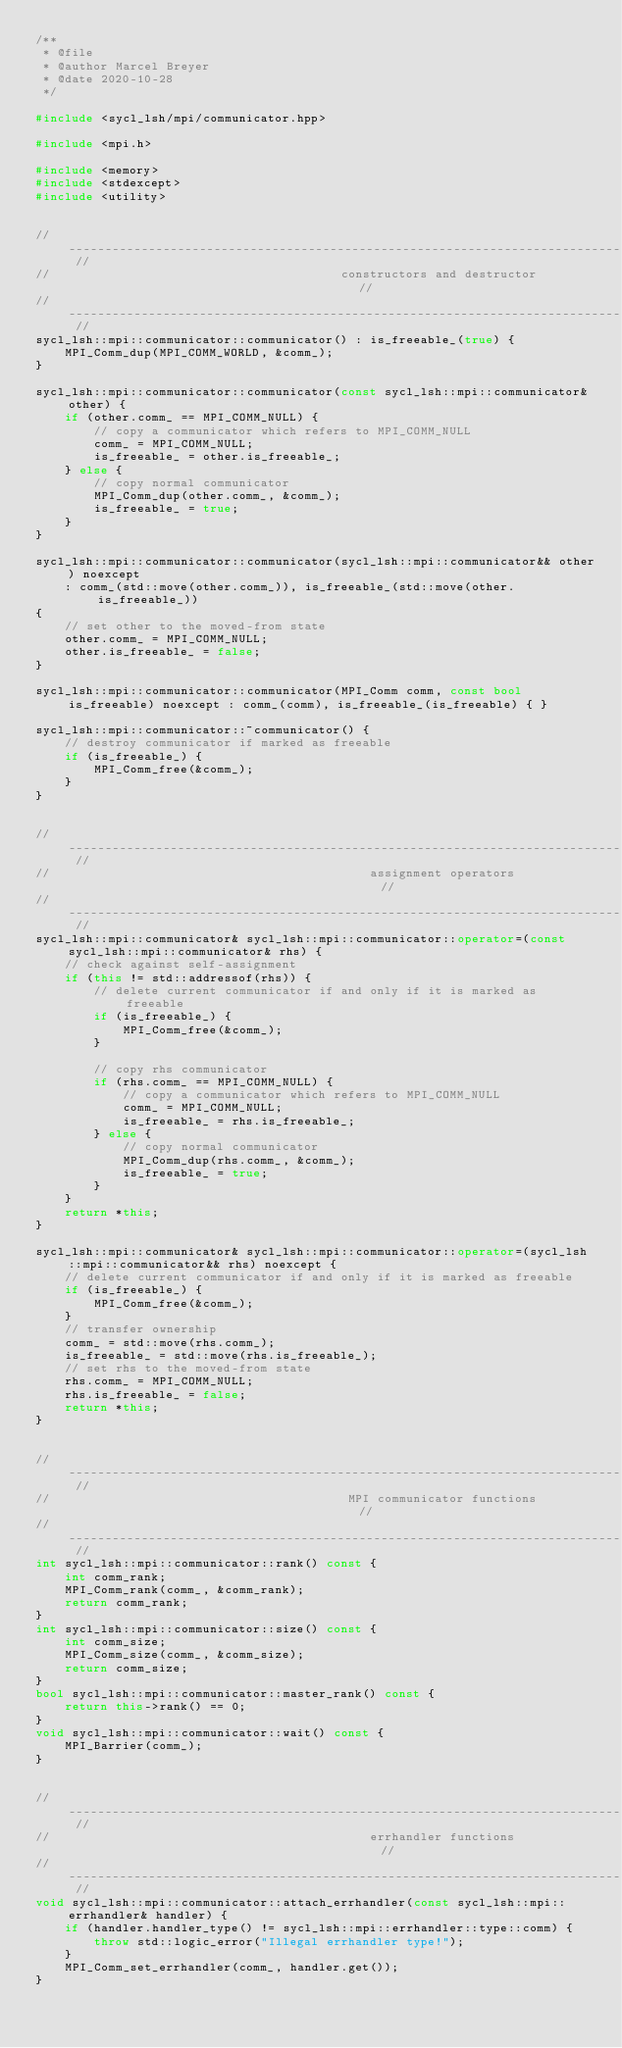Convert code to text. <code><loc_0><loc_0><loc_500><loc_500><_C++_>/**
 * @file
 * @author Marcel Breyer
 * @date 2020-10-28
 */

#include <sycl_lsh/mpi/communicator.hpp>

#include <mpi.h>

#include <memory>
#include <stdexcept>
#include <utility>


// ---------------------------------------------------------------------------------------------------------- //
//                                        constructors and destructor                                         //
// ---------------------------------------------------------------------------------------------------------- //
sycl_lsh::mpi::communicator::communicator() : is_freeable_(true) {
    MPI_Comm_dup(MPI_COMM_WORLD, &comm_);
}

sycl_lsh::mpi::communicator::communicator(const sycl_lsh::mpi::communicator& other) {
    if (other.comm_ == MPI_COMM_NULL) {
        // copy a communicator which refers to MPI_COMM_NULL
        comm_ = MPI_COMM_NULL;
        is_freeable_ = other.is_freeable_;
    } else {
        // copy normal communicator
        MPI_Comm_dup(other.comm_, &comm_);
        is_freeable_ = true;
    }
}

sycl_lsh::mpi::communicator::communicator(sycl_lsh::mpi::communicator&& other) noexcept
    : comm_(std::move(other.comm_)), is_freeable_(std::move(other.is_freeable_))
{
    // set other to the moved-from state
    other.comm_ = MPI_COMM_NULL;
    other.is_freeable_ = false;
}

sycl_lsh::mpi::communicator::communicator(MPI_Comm comm, const bool is_freeable) noexcept : comm_(comm), is_freeable_(is_freeable) { }

sycl_lsh::mpi::communicator::~communicator() {
    // destroy communicator if marked as freeable
    if (is_freeable_) {
        MPI_Comm_free(&comm_);
    }
}


// ---------------------------------------------------------------------------------------------------------- //
//                                            assignment operators                                            //
// ---------------------------------------------------------------------------------------------------------- //
sycl_lsh::mpi::communicator& sycl_lsh::mpi::communicator::operator=(const sycl_lsh::mpi::communicator& rhs) {
    // check against self-assignment
    if (this != std::addressof(rhs)) {
        // delete current communicator if and only if it is marked as freeable
        if (is_freeable_) {
            MPI_Comm_free(&comm_);
        }

        // copy rhs communicator
        if (rhs.comm_ == MPI_COMM_NULL) {
            // copy a communicator which refers to MPI_COMM_NULL
            comm_ = MPI_COMM_NULL;
            is_freeable_ = rhs.is_freeable_;
        } else {
            // copy normal communicator
            MPI_Comm_dup(rhs.comm_, &comm_);
            is_freeable_ = true;
        }
    }
    return *this;
}

sycl_lsh::mpi::communicator& sycl_lsh::mpi::communicator::operator=(sycl_lsh::mpi::communicator&& rhs) noexcept {
    // delete current communicator if and only if it is marked as freeable
    if (is_freeable_) {
        MPI_Comm_free(&comm_);
    }
    // transfer ownership
    comm_ = std::move(rhs.comm_);
    is_freeable_ = std::move(rhs.is_freeable_);
    // set rhs to the moved-from state
    rhs.comm_ = MPI_COMM_NULL;
    rhs.is_freeable_ = false;
    return *this;
}


// ---------------------------------------------------------------------------------------------------------- //
//                                         MPI communicator functions                                         //
// ---------------------------------------------------------------------------------------------------------- //
int sycl_lsh::mpi::communicator::rank() const {
    int comm_rank;
    MPI_Comm_rank(comm_, &comm_rank);
    return comm_rank;
}
int sycl_lsh::mpi::communicator::size() const {
    int comm_size;
    MPI_Comm_size(comm_, &comm_size);
    return comm_size;
}
bool sycl_lsh::mpi::communicator::master_rank() const {
    return this->rank() == 0;
}
void sycl_lsh::mpi::communicator::wait() const {
    MPI_Barrier(comm_);
}


// ---------------------------------------------------------------------------------------------------------- //
//                                            errhandler functions                                            //
// ---------------------------------------------------------------------------------------------------------- //
void sycl_lsh::mpi::communicator::attach_errhandler(const sycl_lsh::mpi::errhandler& handler) {
    if (handler.handler_type() != sycl_lsh::mpi::errhandler::type::comm) {
        throw std::logic_error("Illegal errhandler type!");
    }
    MPI_Comm_set_errhandler(comm_, handler.get());
}</code> 